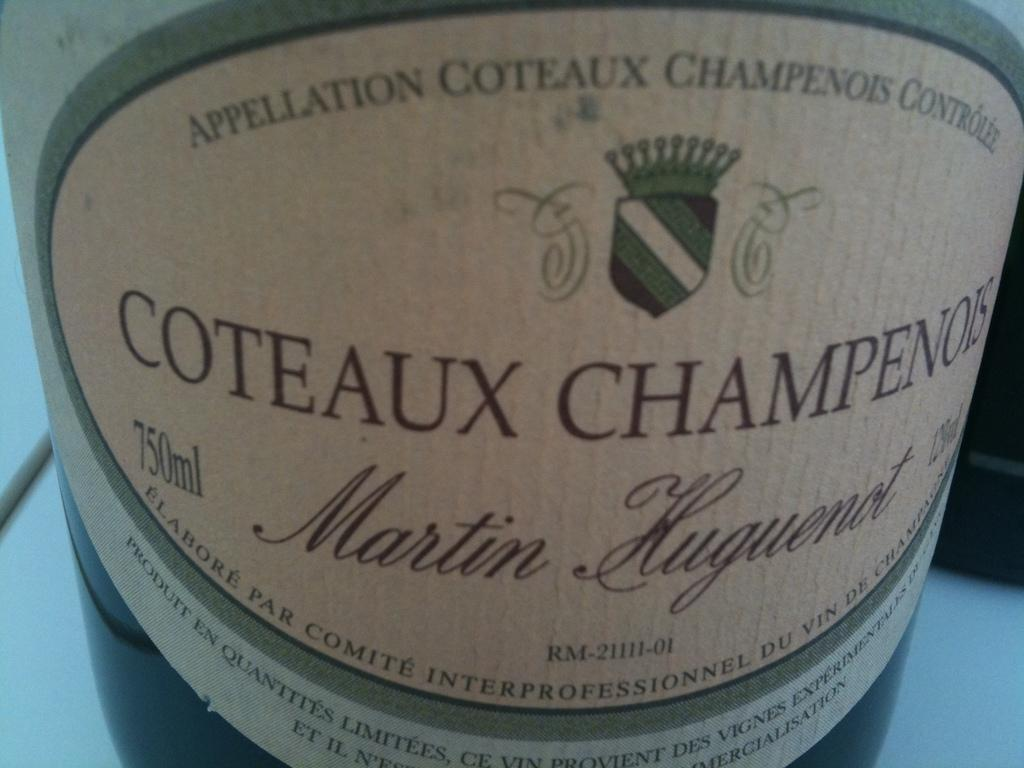<image>
Create a compact narrative representing the image presented. Coteaux Champenois sits on a white clothed table. 